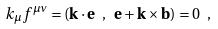<formula> <loc_0><loc_0><loc_500><loc_500>k _ { \mu } f ^ { \mu \nu } = ( { \mathbf k } \cdot { \mathbf e } \ , \ { \mathbf e } + { \mathbf k } \times { \mathbf b } ) = 0 \ ,</formula> 